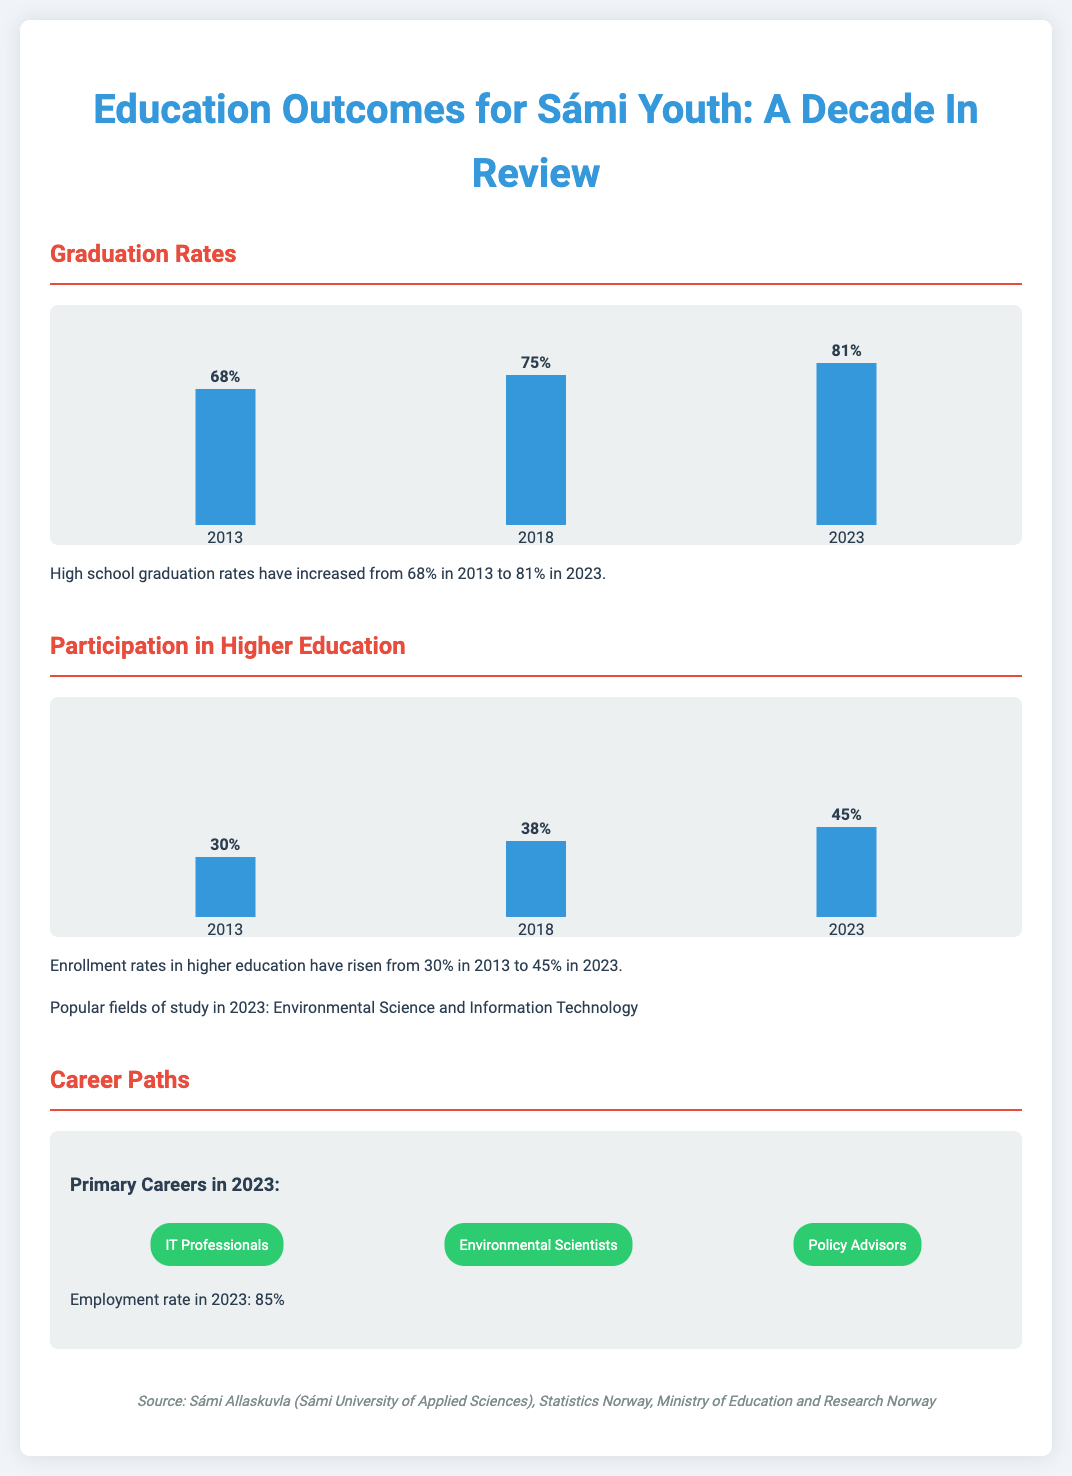What was the graduation rate in 2013? The graduation rate in 2013 is explicitly stated in the document as 68%.
Answer: 68% What is the enrollment rate in higher education for Sámi youth in 2023? The enrollment rate in higher education for 2023 is mentioned in the document as 45%.
Answer: 45% Which career path had the highest employment rate in 2023? The employment rate is explicitly noted as 85%, which applies to all primary careers listed.
Answer: 85% What fields of study saw increased interest in 2023? The document mentions "Environmental Science and Information Technology" as popular fields of study in 2023.
Answer: Environmental Science and Information Technology What was the graduation rate increase from 2013 to 2023? The graduation rate increased from 68% to 81%, which is a difference of 13%.
Answer: 13% How many primary career paths are mentioned for Sámi youth? The document lists three primary career paths in 2023.
Answer: Three What color represents the bars in the graduation rates chart? The color of the bars used for graduation rates is blue.
Answer: Blue What is the main source of the data presented in this infographic? The main source is stated in the document as Sámi Allaskuvla (Sámi University of Applied Sciences), Statistics Norway, Ministry of Education and Research Norway.
Answer: Sámi Allaskuvla (Sámi University of Applied Sciences) What percentage of Sámi youth graduated high school in 2023? The percentage of Sámi youth who graduated high school in 2023 is mentioned as 81%.
Answer: 81% 